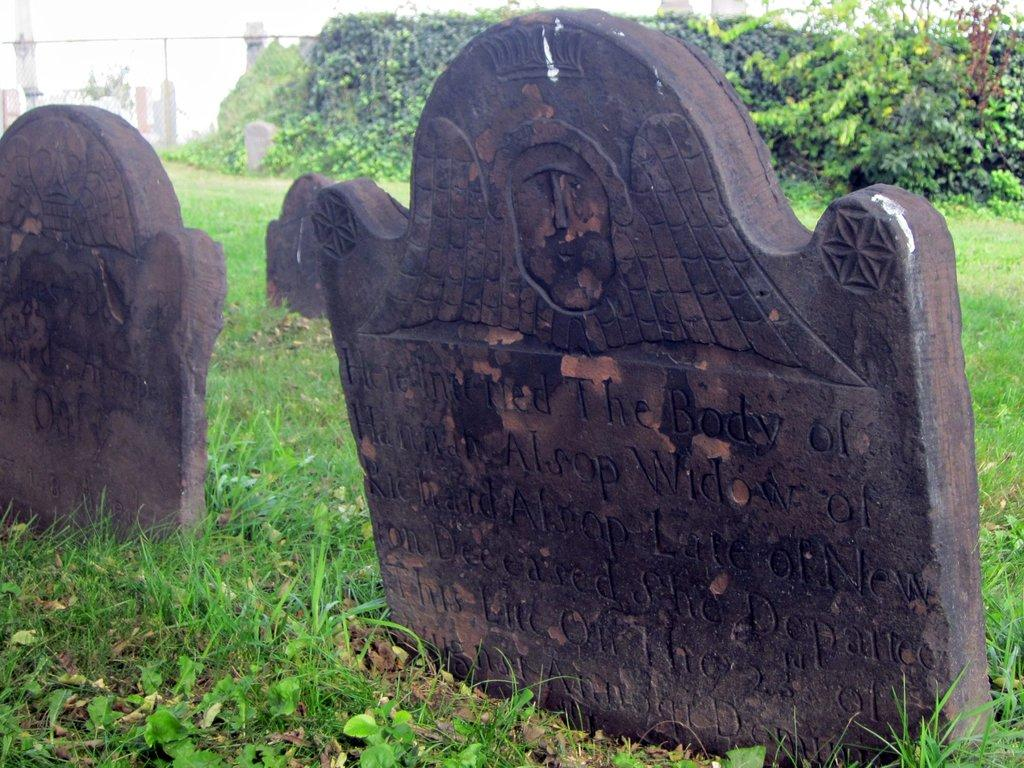What is placed on the grass in the image? There are boards on the grass in the image. What can be seen in the background of the image? There are plants in the background of the image. How many kitties are playing with the spark in the image? There are no kitties or spark present in the image. What type of trees can be seen in the image? There is no mention of trees in the provided facts, so we cannot determine if there are any trees in the image. 